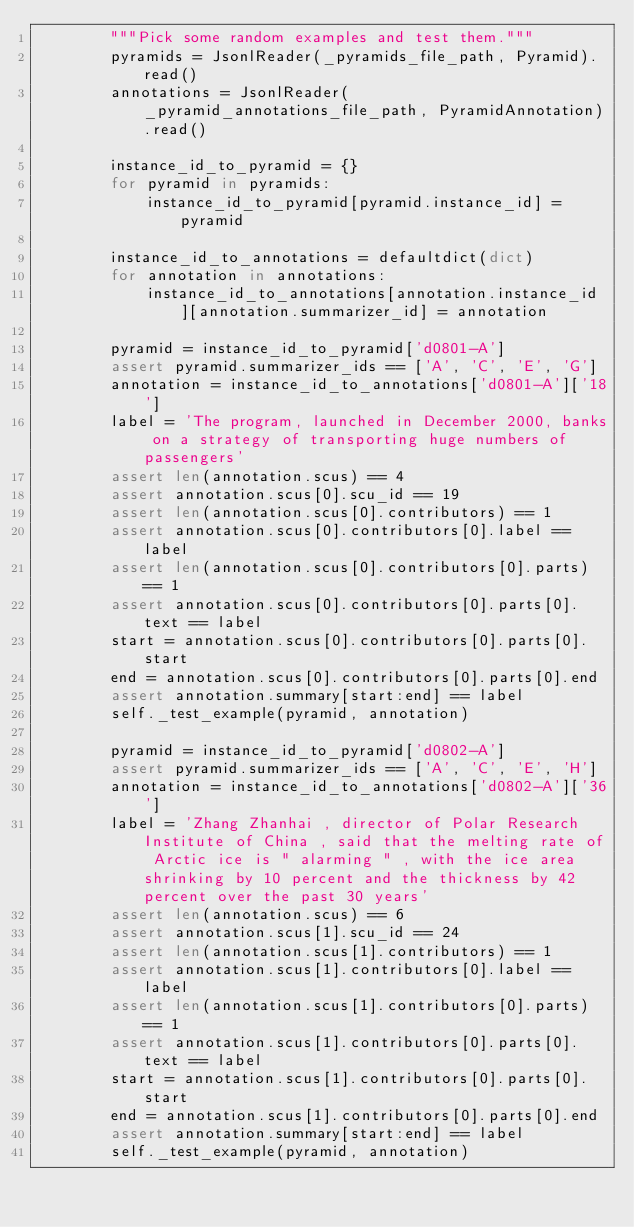Convert code to text. <code><loc_0><loc_0><loc_500><loc_500><_Python_>        """Pick some random examples and test them."""
        pyramids = JsonlReader(_pyramids_file_path, Pyramid).read()
        annotations = JsonlReader(_pyramid_annotations_file_path, PyramidAnnotation).read()

        instance_id_to_pyramid = {}
        for pyramid in pyramids:
            instance_id_to_pyramid[pyramid.instance_id] = pyramid

        instance_id_to_annotations = defaultdict(dict)
        for annotation in annotations:
            instance_id_to_annotations[annotation.instance_id][annotation.summarizer_id] = annotation

        pyramid = instance_id_to_pyramid['d0801-A']
        assert pyramid.summarizer_ids == ['A', 'C', 'E', 'G']
        annotation = instance_id_to_annotations['d0801-A']['18']
        label = 'The program, launched in December 2000, banks on a strategy of transporting huge numbers of passengers'
        assert len(annotation.scus) == 4
        assert annotation.scus[0].scu_id == 19
        assert len(annotation.scus[0].contributors) == 1
        assert annotation.scus[0].contributors[0].label == label
        assert len(annotation.scus[0].contributors[0].parts) == 1
        assert annotation.scus[0].contributors[0].parts[0].text == label
        start = annotation.scus[0].contributors[0].parts[0].start
        end = annotation.scus[0].contributors[0].parts[0].end
        assert annotation.summary[start:end] == label
        self._test_example(pyramid, annotation)

        pyramid = instance_id_to_pyramid['d0802-A']
        assert pyramid.summarizer_ids == ['A', 'C', 'E', 'H']
        annotation = instance_id_to_annotations['d0802-A']['36']
        label = 'Zhang Zhanhai , director of Polar Research Institute of China , said that the melting rate of Arctic ice is " alarming " , with the ice area shrinking by 10 percent and the thickness by 42 percent over the past 30 years'
        assert len(annotation.scus) == 6
        assert annotation.scus[1].scu_id == 24
        assert len(annotation.scus[1].contributors) == 1
        assert annotation.scus[1].contributors[0].label == label
        assert len(annotation.scus[1].contributors[0].parts) == 1
        assert annotation.scus[1].contributors[0].parts[0].text == label
        start = annotation.scus[1].contributors[0].parts[0].start
        end = annotation.scus[1].contributors[0].parts[0].end
        assert annotation.summary[start:end] == label
        self._test_example(pyramid, annotation)
</code> 